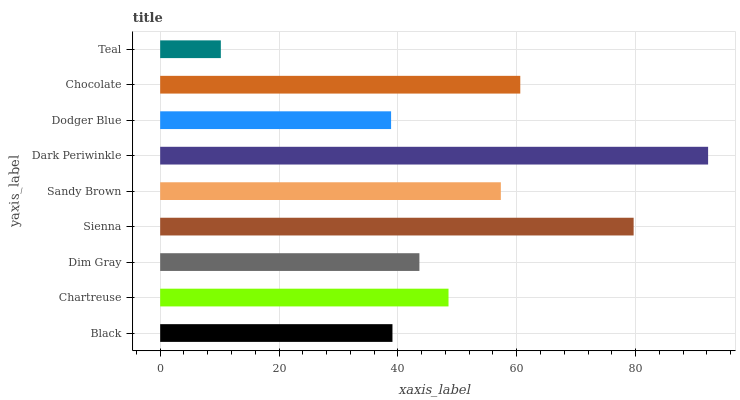Is Teal the minimum?
Answer yes or no. Yes. Is Dark Periwinkle the maximum?
Answer yes or no. Yes. Is Chartreuse the minimum?
Answer yes or no. No. Is Chartreuse the maximum?
Answer yes or no. No. Is Chartreuse greater than Black?
Answer yes or no. Yes. Is Black less than Chartreuse?
Answer yes or no. Yes. Is Black greater than Chartreuse?
Answer yes or no. No. Is Chartreuse less than Black?
Answer yes or no. No. Is Chartreuse the high median?
Answer yes or no. Yes. Is Chartreuse the low median?
Answer yes or no. Yes. Is Dark Periwinkle the high median?
Answer yes or no. No. Is Teal the low median?
Answer yes or no. No. 